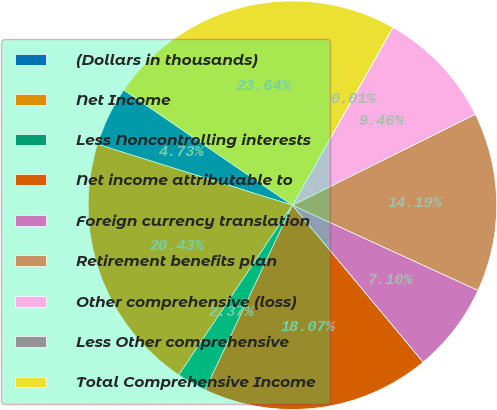<chart> <loc_0><loc_0><loc_500><loc_500><pie_chart><fcel>(Dollars in thousands)<fcel>Net Income<fcel>Less Noncontrolling interests<fcel>Net income attributable to<fcel>Foreign currency translation<fcel>Retirement benefits plan<fcel>Other comprehensive (loss)<fcel>Less Other comprehensive<fcel>Total Comprehensive Income<nl><fcel>4.73%<fcel>20.43%<fcel>2.37%<fcel>18.07%<fcel>7.1%<fcel>14.19%<fcel>9.46%<fcel>0.01%<fcel>23.64%<nl></chart> 